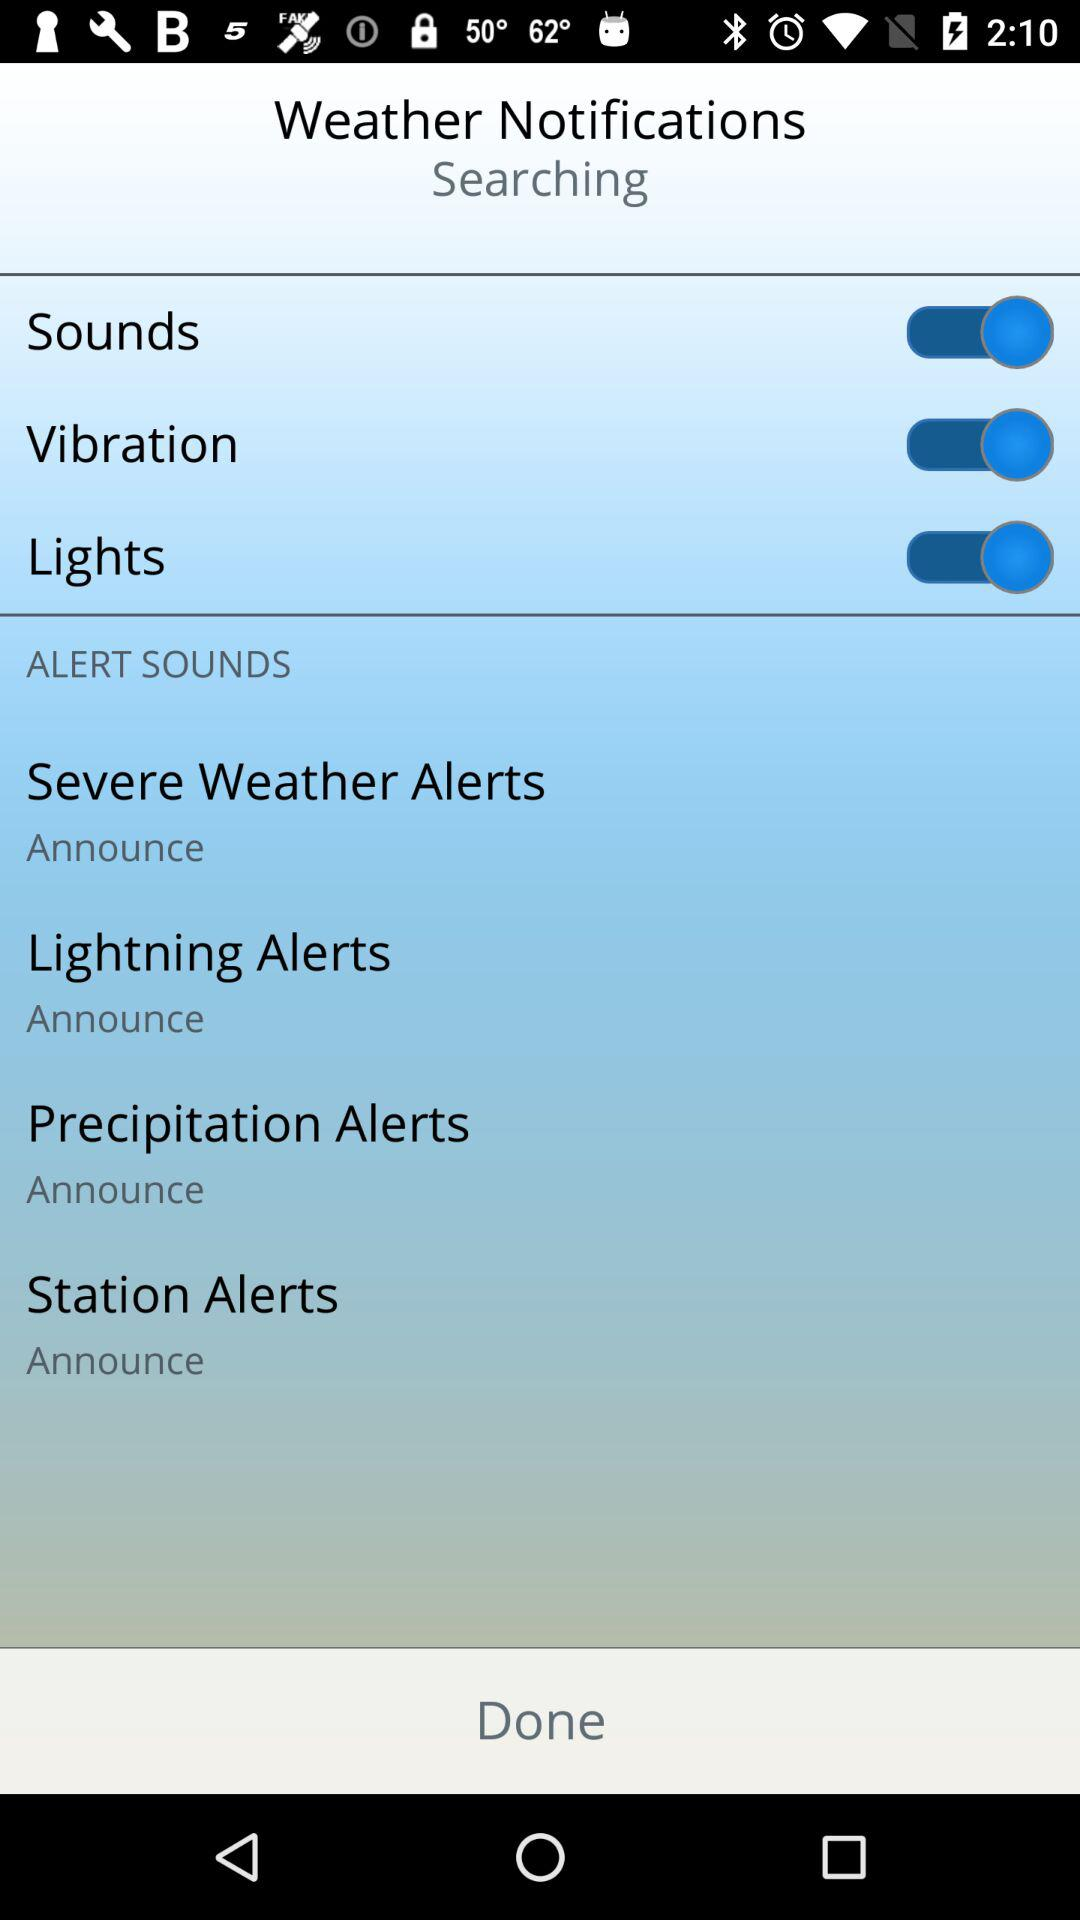What is the status of the "Sounds"? The status of the "Sounds" is "on". 